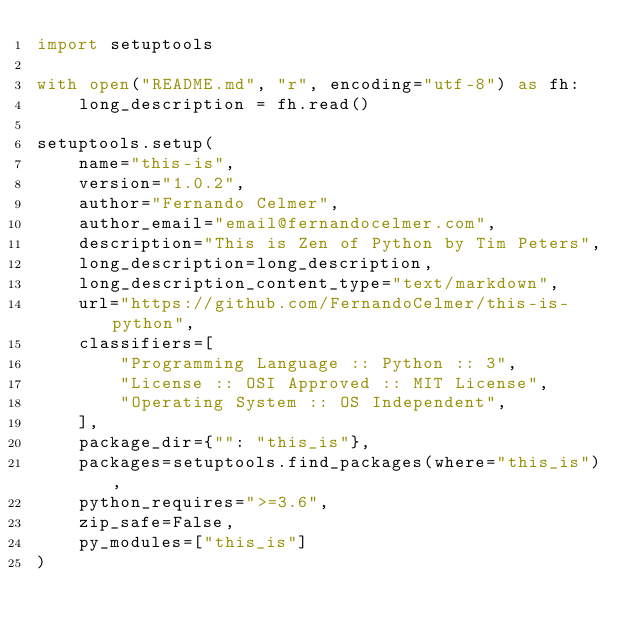<code> <loc_0><loc_0><loc_500><loc_500><_Python_>import setuptools

with open("README.md", "r", encoding="utf-8") as fh:
    long_description = fh.read()

setuptools.setup(
    name="this-is",
    version="1.0.2",
    author="Fernando Celmer",
    author_email="email@fernandocelmer.com",
    description="This is Zen of Python by Tim Peters",
    long_description=long_description,
    long_description_content_type="text/markdown",
    url="https://github.com/FernandoCelmer/this-is-python",
    classifiers=[
        "Programming Language :: Python :: 3",
        "License :: OSI Approved :: MIT License",
        "Operating System :: OS Independent",
    ],
    package_dir={"": "this_is"},
    packages=setuptools.find_packages(where="this_is"),
    python_requires=">=3.6",
    zip_safe=False,
    py_modules=["this_is"]
)</code> 